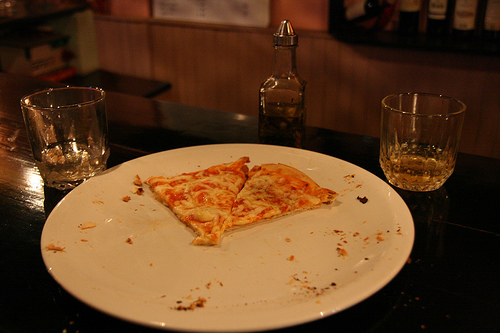How many slices of pizza have been eaten based on the leftovers on the plate? It looks like at least three or possibly four slices have been consumed, judging by the arrangement and the amount of crumbs and oil left on the plate. 